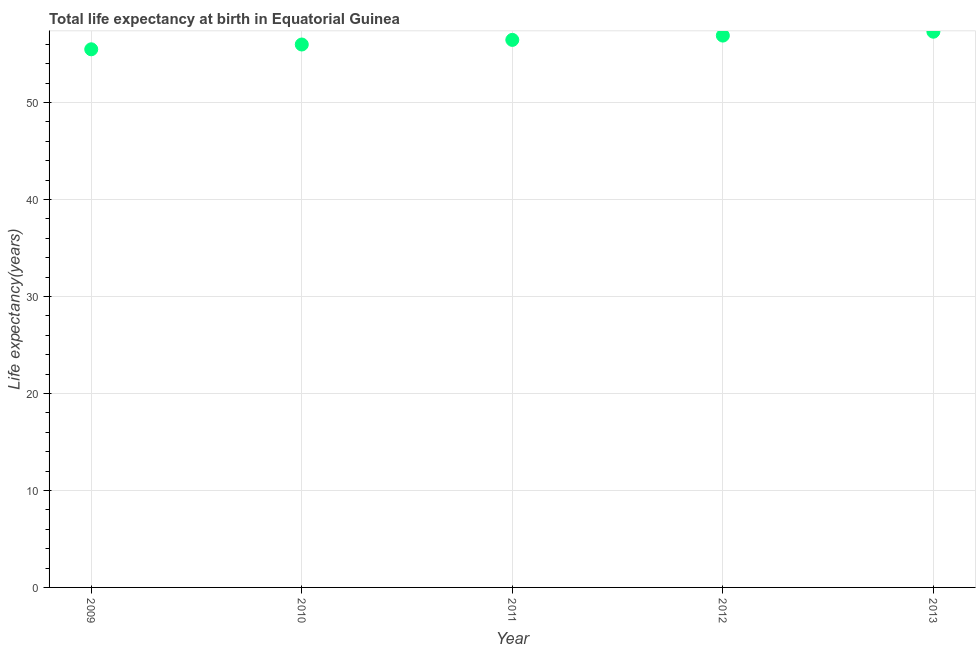What is the life expectancy at birth in 2010?
Ensure brevity in your answer.  55.97. Across all years, what is the maximum life expectancy at birth?
Provide a succinct answer. 57.29. Across all years, what is the minimum life expectancy at birth?
Provide a short and direct response. 55.48. In which year was the life expectancy at birth maximum?
Your response must be concise. 2013. In which year was the life expectancy at birth minimum?
Give a very brief answer. 2009. What is the sum of the life expectancy at birth?
Make the answer very short. 282.08. What is the difference between the life expectancy at birth in 2009 and 2011?
Keep it short and to the point. -0.97. What is the average life expectancy at birth per year?
Ensure brevity in your answer.  56.42. What is the median life expectancy at birth?
Your answer should be very brief. 56.45. In how many years, is the life expectancy at birth greater than 24 years?
Keep it short and to the point. 5. Do a majority of the years between 2012 and 2011 (inclusive) have life expectancy at birth greater than 52 years?
Provide a succinct answer. No. What is the ratio of the life expectancy at birth in 2009 to that in 2011?
Your response must be concise. 0.98. Is the difference between the life expectancy at birth in 2011 and 2012 greater than the difference between any two years?
Offer a very short reply. No. What is the difference between the highest and the second highest life expectancy at birth?
Offer a very short reply. 0.4. What is the difference between the highest and the lowest life expectancy at birth?
Your answer should be compact. 1.81. How many years are there in the graph?
Your response must be concise. 5. What is the difference between two consecutive major ticks on the Y-axis?
Give a very brief answer. 10. Does the graph contain any zero values?
Offer a very short reply. No. Does the graph contain grids?
Your response must be concise. Yes. What is the title of the graph?
Keep it short and to the point. Total life expectancy at birth in Equatorial Guinea. What is the label or title of the X-axis?
Offer a terse response. Year. What is the label or title of the Y-axis?
Provide a succinct answer. Life expectancy(years). What is the Life expectancy(years) in 2009?
Provide a short and direct response. 55.48. What is the Life expectancy(years) in 2010?
Give a very brief answer. 55.97. What is the Life expectancy(years) in 2011?
Make the answer very short. 56.45. What is the Life expectancy(years) in 2012?
Your answer should be very brief. 56.89. What is the Life expectancy(years) in 2013?
Offer a terse response. 57.29. What is the difference between the Life expectancy(years) in 2009 and 2010?
Offer a terse response. -0.49. What is the difference between the Life expectancy(years) in 2009 and 2011?
Offer a terse response. -0.97. What is the difference between the Life expectancy(years) in 2009 and 2012?
Your answer should be very brief. -1.41. What is the difference between the Life expectancy(years) in 2009 and 2013?
Make the answer very short. -1.81. What is the difference between the Life expectancy(years) in 2010 and 2011?
Your answer should be compact. -0.48. What is the difference between the Life expectancy(years) in 2010 and 2012?
Make the answer very short. -0.92. What is the difference between the Life expectancy(years) in 2010 and 2013?
Ensure brevity in your answer.  -1.32. What is the difference between the Life expectancy(years) in 2011 and 2012?
Provide a short and direct response. -0.44. What is the difference between the Life expectancy(years) in 2011 and 2013?
Offer a terse response. -0.84. What is the difference between the Life expectancy(years) in 2012 and 2013?
Your response must be concise. -0.4. What is the ratio of the Life expectancy(years) in 2009 to that in 2010?
Provide a succinct answer. 0.99. What is the ratio of the Life expectancy(years) in 2009 to that in 2011?
Your answer should be very brief. 0.98. What is the ratio of the Life expectancy(years) in 2009 to that in 2012?
Provide a succinct answer. 0.97. What is the ratio of the Life expectancy(years) in 2010 to that in 2013?
Offer a very short reply. 0.98. What is the ratio of the Life expectancy(years) in 2011 to that in 2012?
Your response must be concise. 0.99. What is the ratio of the Life expectancy(years) in 2011 to that in 2013?
Provide a succinct answer. 0.98. What is the ratio of the Life expectancy(years) in 2012 to that in 2013?
Offer a terse response. 0.99. 